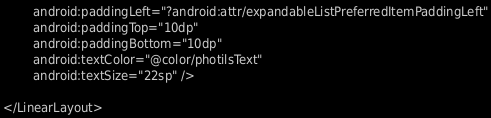<code> <loc_0><loc_0><loc_500><loc_500><_XML_>        android:paddingLeft="?android:attr/expandableListPreferredItemPaddingLeft"
        android:paddingTop="10dp"
        android:paddingBottom="10dp"
        android:textColor="@color/photilsText"
        android:textSize="22sp" />

</LinearLayout>
</code> 